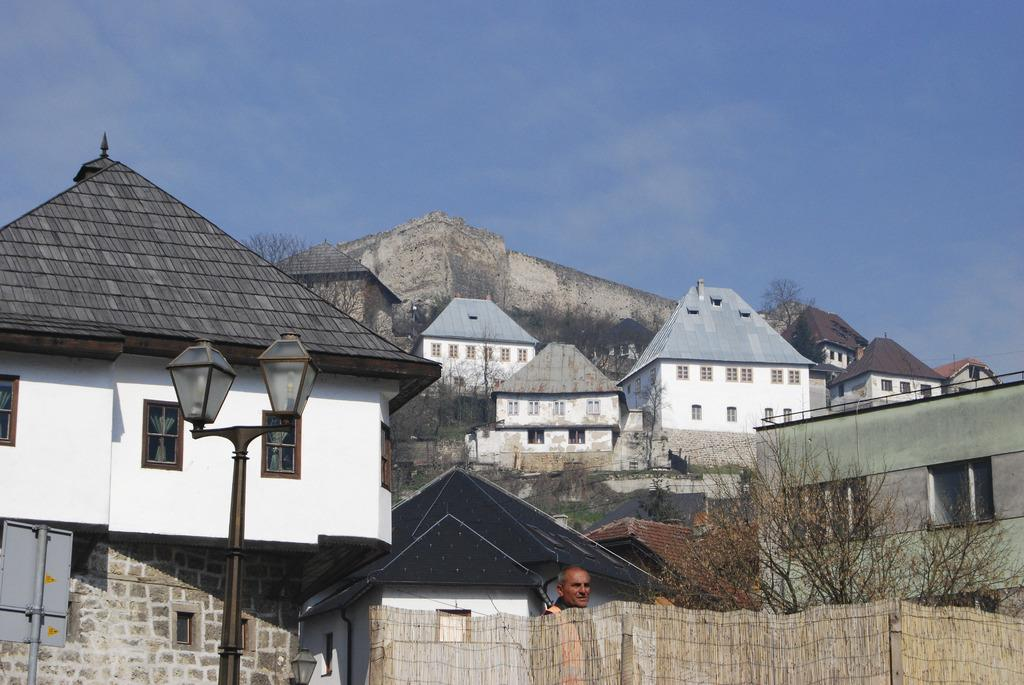What type of structure is visible in the image? There is a fort in the image. What other types of structures can be seen in the image? There are buildings in the image. What natural elements are present in the image? There are trees in the image. Can you describe the person in the image? There is a person in the image. What type of barrier is present in the image? There is fencing in the image. What type of lighting is visible in the image? There is a streetlight in the image. What can be seen in the sky in the image? The sky is visible in the image, and there are clouds present. What type of faucet is visible in the image? There is no faucet present in the image. What color is the coat worn by the person in the image? There is no coat visible in the image; the person is not wearing one. 